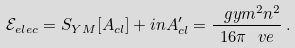<formula> <loc_0><loc_0><loc_500><loc_500>\mathcal { E } _ { e l e c } = S _ { Y M } [ A _ { c l } ] + i n A ^ { \prime } _ { c l } = \frac { \ g y m ^ { 2 } n ^ { 2 } } { 1 6 \pi \ v e } \, .</formula> 